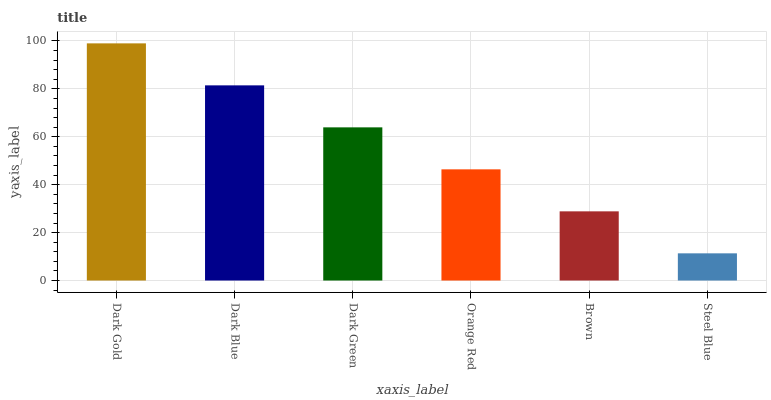Is Steel Blue the minimum?
Answer yes or no. Yes. Is Dark Gold the maximum?
Answer yes or no. Yes. Is Dark Blue the minimum?
Answer yes or no. No. Is Dark Blue the maximum?
Answer yes or no. No. Is Dark Gold greater than Dark Blue?
Answer yes or no. Yes. Is Dark Blue less than Dark Gold?
Answer yes or no. Yes. Is Dark Blue greater than Dark Gold?
Answer yes or no. No. Is Dark Gold less than Dark Blue?
Answer yes or no. No. Is Dark Green the high median?
Answer yes or no. Yes. Is Orange Red the low median?
Answer yes or no. Yes. Is Orange Red the high median?
Answer yes or no. No. Is Brown the low median?
Answer yes or no. No. 